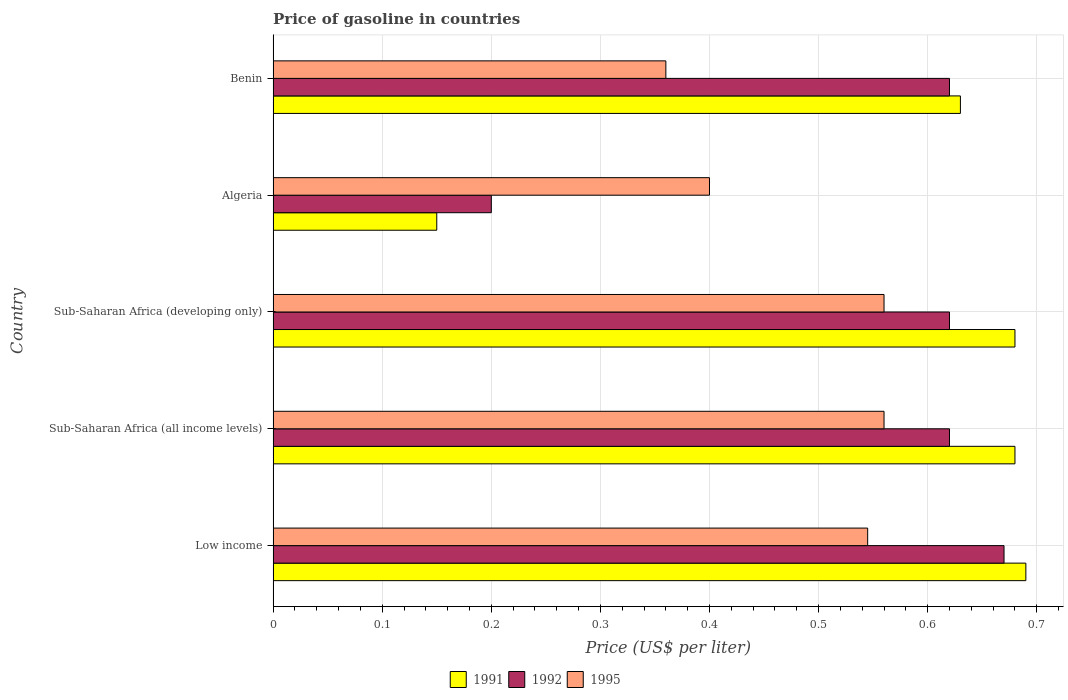How many different coloured bars are there?
Make the answer very short. 3. How many groups of bars are there?
Ensure brevity in your answer.  5. Are the number of bars per tick equal to the number of legend labels?
Provide a short and direct response. Yes. Are the number of bars on each tick of the Y-axis equal?
Offer a terse response. Yes. How many bars are there on the 3rd tick from the top?
Ensure brevity in your answer.  3. What is the price of gasoline in 1992 in Low income?
Offer a terse response. 0.67. Across all countries, what is the maximum price of gasoline in 1992?
Offer a very short reply. 0.67. In which country was the price of gasoline in 1992 maximum?
Keep it short and to the point. Low income. In which country was the price of gasoline in 1992 minimum?
Make the answer very short. Algeria. What is the total price of gasoline in 1991 in the graph?
Offer a very short reply. 2.83. What is the difference between the price of gasoline in 1991 in Algeria and that in Sub-Saharan Africa (all income levels)?
Your answer should be very brief. -0.53. What is the difference between the price of gasoline in 1992 in Algeria and the price of gasoline in 1991 in Sub-Saharan Africa (all income levels)?
Your answer should be very brief. -0.48. What is the average price of gasoline in 1991 per country?
Offer a very short reply. 0.57. What is the difference between the price of gasoline in 1995 and price of gasoline in 1992 in Benin?
Your answer should be compact. -0.26. Is the difference between the price of gasoline in 1995 in Low income and Sub-Saharan Africa (all income levels) greater than the difference between the price of gasoline in 1992 in Low income and Sub-Saharan Africa (all income levels)?
Ensure brevity in your answer.  No. What is the difference between the highest and the second highest price of gasoline in 1995?
Your answer should be very brief. 0. What is the difference between the highest and the lowest price of gasoline in 1992?
Keep it short and to the point. 0.47. In how many countries, is the price of gasoline in 1992 greater than the average price of gasoline in 1992 taken over all countries?
Give a very brief answer. 4. What does the 1st bar from the bottom in Sub-Saharan Africa (all income levels) represents?
Your response must be concise. 1991. Is it the case that in every country, the sum of the price of gasoline in 1992 and price of gasoline in 1995 is greater than the price of gasoline in 1991?
Offer a very short reply. Yes. How many bars are there?
Make the answer very short. 15. Are all the bars in the graph horizontal?
Make the answer very short. Yes. What is the difference between two consecutive major ticks on the X-axis?
Offer a terse response. 0.1. Does the graph contain grids?
Your answer should be compact. Yes. What is the title of the graph?
Make the answer very short. Price of gasoline in countries. Does "1980" appear as one of the legend labels in the graph?
Your answer should be very brief. No. What is the label or title of the X-axis?
Provide a succinct answer. Price (US$ per liter). What is the label or title of the Y-axis?
Provide a short and direct response. Country. What is the Price (US$ per liter) in 1991 in Low income?
Your answer should be compact. 0.69. What is the Price (US$ per liter) in 1992 in Low income?
Keep it short and to the point. 0.67. What is the Price (US$ per liter) of 1995 in Low income?
Your answer should be very brief. 0.55. What is the Price (US$ per liter) of 1991 in Sub-Saharan Africa (all income levels)?
Offer a terse response. 0.68. What is the Price (US$ per liter) of 1992 in Sub-Saharan Africa (all income levels)?
Your answer should be compact. 0.62. What is the Price (US$ per liter) in 1995 in Sub-Saharan Africa (all income levels)?
Your answer should be compact. 0.56. What is the Price (US$ per liter) in 1991 in Sub-Saharan Africa (developing only)?
Offer a very short reply. 0.68. What is the Price (US$ per liter) in 1992 in Sub-Saharan Africa (developing only)?
Your response must be concise. 0.62. What is the Price (US$ per liter) in 1995 in Sub-Saharan Africa (developing only)?
Ensure brevity in your answer.  0.56. What is the Price (US$ per liter) in 1995 in Algeria?
Make the answer very short. 0.4. What is the Price (US$ per liter) in 1991 in Benin?
Provide a succinct answer. 0.63. What is the Price (US$ per liter) in 1992 in Benin?
Make the answer very short. 0.62. What is the Price (US$ per liter) of 1995 in Benin?
Provide a short and direct response. 0.36. Across all countries, what is the maximum Price (US$ per liter) in 1991?
Offer a very short reply. 0.69. Across all countries, what is the maximum Price (US$ per liter) of 1992?
Make the answer very short. 0.67. Across all countries, what is the maximum Price (US$ per liter) of 1995?
Ensure brevity in your answer.  0.56. Across all countries, what is the minimum Price (US$ per liter) of 1992?
Give a very brief answer. 0.2. Across all countries, what is the minimum Price (US$ per liter) in 1995?
Offer a very short reply. 0.36. What is the total Price (US$ per liter) in 1991 in the graph?
Your answer should be compact. 2.83. What is the total Price (US$ per liter) in 1992 in the graph?
Your response must be concise. 2.73. What is the total Price (US$ per liter) in 1995 in the graph?
Keep it short and to the point. 2.42. What is the difference between the Price (US$ per liter) in 1995 in Low income and that in Sub-Saharan Africa (all income levels)?
Keep it short and to the point. -0.01. What is the difference between the Price (US$ per liter) of 1992 in Low income and that in Sub-Saharan Africa (developing only)?
Provide a succinct answer. 0.05. What is the difference between the Price (US$ per liter) in 1995 in Low income and that in Sub-Saharan Africa (developing only)?
Your answer should be compact. -0.01. What is the difference between the Price (US$ per liter) of 1991 in Low income and that in Algeria?
Offer a terse response. 0.54. What is the difference between the Price (US$ per liter) in 1992 in Low income and that in Algeria?
Your answer should be very brief. 0.47. What is the difference between the Price (US$ per liter) in 1995 in Low income and that in Algeria?
Offer a terse response. 0.14. What is the difference between the Price (US$ per liter) of 1995 in Low income and that in Benin?
Your response must be concise. 0.18. What is the difference between the Price (US$ per liter) in 1991 in Sub-Saharan Africa (all income levels) and that in Algeria?
Your response must be concise. 0.53. What is the difference between the Price (US$ per liter) in 1992 in Sub-Saharan Africa (all income levels) and that in Algeria?
Your answer should be very brief. 0.42. What is the difference between the Price (US$ per liter) of 1995 in Sub-Saharan Africa (all income levels) and that in Algeria?
Give a very brief answer. 0.16. What is the difference between the Price (US$ per liter) in 1992 in Sub-Saharan Africa (all income levels) and that in Benin?
Provide a succinct answer. 0. What is the difference between the Price (US$ per liter) in 1991 in Sub-Saharan Africa (developing only) and that in Algeria?
Offer a very short reply. 0.53. What is the difference between the Price (US$ per liter) in 1992 in Sub-Saharan Africa (developing only) and that in Algeria?
Ensure brevity in your answer.  0.42. What is the difference between the Price (US$ per liter) of 1995 in Sub-Saharan Africa (developing only) and that in Algeria?
Keep it short and to the point. 0.16. What is the difference between the Price (US$ per liter) of 1995 in Sub-Saharan Africa (developing only) and that in Benin?
Your answer should be compact. 0.2. What is the difference between the Price (US$ per liter) in 1991 in Algeria and that in Benin?
Ensure brevity in your answer.  -0.48. What is the difference between the Price (US$ per liter) of 1992 in Algeria and that in Benin?
Offer a very short reply. -0.42. What is the difference between the Price (US$ per liter) of 1995 in Algeria and that in Benin?
Give a very brief answer. 0.04. What is the difference between the Price (US$ per liter) of 1991 in Low income and the Price (US$ per liter) of 1992 in Sub-Saharan Africa (all income levels)?
Give a very brief answer. 0.07. What is the difference between the Price (US$ per liter) of 1991 in Low income and the Price (US$ per liter) of 1995 in Sub-Saharan Africa (all income levels)?
Give a very brief answer. 0.13. What is the difference between the Price (US$ per liter) of 1992 in Low income and the Price (US$ per liter) of 1995 in Sub-Saharan Africa (all income levels)?
Provide a succinct answer. 0.11. What is the difference between the Price (US$ per liter) in 1991 in Low income and the Price (US$ per liter) in 1992 in Sub-Saharan Africa (developing only)?
Your answer should be compact. 0.07. What is the difference between the Price (US$ per liter) of 1991 in Low income and the Price (US$ per liter) of 1995 in Sub-Saharan Africa (developing only)?
Offer a terse response. 0.13. What is the difference between the Price (US$ per liter) of 1992 in Low income and the Price (US$ per liter) of 1995 in Sub-Saharan Africa (developing only)?
Offer a very short reply. 0.11. What is the difference between the Price (US$ per liter) of 1991 in Low income and the Price (US$ per liter) of 1992 in Algeria?
Make the answer very short. 0.49. What is the difference between the Price (US$ per liter) in 1991 in Low income and the Price (US$ per liter) in 1995 in Algeria?
Offer a terse response. 0.29. What is the difference between the Price (US$ per liter) in 1992 in Low income and the Price (US$ per liter) in 1995 in Algeria?
Offer a terse response. 0.27. What is the difference between the Price (US$ per liter) in 1991 in Low income and the Price (US$ per liter) in 1992 in Benin?
Keep it short and to the point. 0.07. What is the difference between the Price (US$ per liter) of 1991 in Low income and the Price (US$ per liter) of 1995 in Benin?
Offer a terse response. 0.33. What is the difference between the Price (US$ per liter) of 1992 in Low income and the Price (US$ per liter) of 1995 in Benin?
Provide a short and direct response. 0.31. What is the difference between the Price (US$ per liter) in 1991 in Sub-Saharan Africa (all income levels) and the Price (US$ per liter) in 1995 in Sub-Saharan Africa (developing only)?
Your answer should be compact. 0.12. What is the difference between the Price (US$ per liter) in 1991 in Sub-Saharan Africa (all income levels) and the Price (US$ per liter) in 1992 in Algeria?
Your response must be concise. 0.48. What is the difference between the Price (US$ per liter) of 1991 in Sub-Saharan Africa (all income levels) and the Price (US$ per liter) of 1995 in Algeria?
Your answer should be compact. 0.28. What is the difference between the Price (US$ per liter) of 1992 in Sub-Saharan Africa (all income levels) and the Price (US$ per liter) of 1995 in Algeria?
Make the answer very short. 0.22. What is the difference between the Price (US$ per liter) in 1991 in Sub-Saharan Africa (all income levels) and the Price (US$ per liter) in 1992 in Benin?
Offer a very short reply. 0.06. What is the difference between the Price (US$ per liter) in 1991 in Sub-Saharan Africa (all income levels) and the Price (US$ per liter) in 1995 in Benin?
Your answer should be compact. 0.32. What is the difference between the Price (US$ per liter) in 1992 in Sub-Saharan Africa (all income levels) and the Price (US$ per liter) in 1995 in Benin?
Your answer should be very brief. 0.26. What is the difference between the Price (US$ per liter) of 1991 in Sub-Saharan Africa (developing only) and the Price (US$ per liter) of 1992 in Algeria?
Keep it short and to the point. 0.48. What is the difference between the Price (US$ per liter) in 1991 in Sub-Saharan Africa (developing only) and the Price (US$ per liter) in 1995 in Algeria?
Keep it short and to the point. 0.28. What is the difference between the Price (US$ per liter) of 1992 in Sub-Saharan Africa (developing only) and the Price (US$ per liter) of 1995 in Algeria?
Ensure brevity in your answer.  0.22. What is the difference between the Price (US$ per liter) of 1991 in Sub-Saharan Africa (developing only) and the Price (US$ per liter) of 1992 in Benin?
Your answer should be compact. 0.06. What is the difference between the Price (US$ per liter) in 1991 in Sub-Saharan Africa (developing only) and the Price (US$ per liter) in 1995 in Benin?
Keep it short and to the point. 0.32. What is the difference between the Price (US$ per liter) in 1992 in Sub-Saharan Africa (developing only) and the Price (US$ per liter) in 1995 in Benin?
Ensure brevity in your answer.  0.26. What is the difference between the Price (US$ per liter) in 1991 in Algeria and the Price (US$ per liter) in 1992 in Benin?
Your response must be concise. -0.47. What is the difference between the Price (US$ per liter) in 1991 in Algeria and the Price (US$ per liter) in 1995 in Benin?
Your answer should be very brief. -0.21. What is the difference between the Price (US$ per liter) of 1992 in Algeria and the Price (US$ per liter) of 1995 in Benin?
Provide a succinct answer. -0.16. What is the average Price (US$ per liter) of 1991 per country?
Your answer should be compact. 0.57. What is the average Price (US$ per liter) of 1992 per country?
Your answer should be compact. 0.55. What is the average Price (US$ per liter) in 1995 per country?
Your answer should be compact. 0.48. What is the difference between the Price (US$ per liter) of 1991 and Price (US$ per liter) of 1995 in Low income?
Offer a terse response. 0.14. What is the difference between the Price (US$ per liter) of 1992 and Price (US$ per liter) of 1995 in Low income?
Your answer should be compact. 0.12. What is the difference between the Price (US$ per liter) of 1991 and Price (US$ per liter) of 1995 in Sub-Saharan Africa (all income levels)?
Your response must be concise. 0.12. What is the difference between the Price (US$ per liter) of 1992 and Price (US$ per liter) of 1995 in Sub-Saharan Africa (all income levels)?
Keep it short and to the point. 0.06. What is the difference between the Price (US$ per liter) of 1991 and Price (US$ per liter) of 1995 in Sub-Saharan Africa (developing only)?
Offer a terse response. 0.12. What is the difference between the Price (US$ per liter) of 1991 and Price (US$ per liter) of 1992 in Algeria?
Your answer should be compact. -0.05. What is the difference between the Price (US$ per liter) of 1991 and Price (US$ per liter) of 1992 in Benin?
Your answer should be compact. 0.01. What is the difference between the Price (US$ per liter) in 1991 and Price (US$ per liter) in 1995 in Benin?
Your answer should be very brief. 0.27. What is the difference between the Price (US$ per liter) in 1992 and Price (US$ per liter) in 1995 in Benin?
Make the answer very short. 0.26. What is the ratio of the Price (US$ per liter) in 1991 in Low income to that in Sub-Saharan Africa (all income levels)?
Your answer should be very brief. 1.01. What is the ratio of the Price (US$ per liter) in 1992 in Low income to that in Sub-Saharan Africa (all income levels)?
Your answer should be compact. 1.08. What is the ratio of the Price (US$ per liter) in 1995 in Low income to that in Sub-Saharan Africa (all income levels)?
Ensure brevity in your answer.  0.97. What is the ratio of the Price (US$ per liter) of 1991 in Low income to that in Sub-Saharan Africa (developing only)?
Your answer should be very brief. 1.01. What is the ratio of the Price (US$ per liter) in 1992 in Low income to that in Sub-Saharan Africa (developing only)?
Offer a very short reply. 1.08. What is the ratio of the Price (US$ per liter) of 1995 in Low income to that in Sub-Saharan Africa (developing only)?
Your answer should be compact. 0.97. What is the ratio of the Price (US$ per liter) of 1991 in Low income to that in Algeria?
Offer a terse response. 4.6. What is the ratio of the Price (US$ per liter) of 1992 in Low income to that in Algeria?
Ensure brevity in your answer.  3.35. What is the ratio of the Price (US$ per liter) of 1995 in Low income to that in Algeria?
Offer a very short reply. 1.36. What is the ratio of the Price (US$ per liter) of 1991 in Low income to that in Benin?
Offer a very short reply. 1.1. What is the ratio of the Price (US$ per liter) of 1992 in Low income to that in Benin?
Keep it short and to the point. 1.08. What is the ratio of the Price (US$ per liter) in 1995 in Low income to that in Benin?
Your answer should be compact. 1.51. What is the ratio of the Price (US$ per liter) in 1992 in Sub-Saharan Africa (all income levels) to that in Sub-Saharan Africa (developing only)?
Offer a terse response. 1. What is the ratio of the Price (US$ per liter) of 1995 in Sub-Saharan Africa (all income levels) to that in Sub-Saharan Africa (developing only)?
Offer a terse response. 1. What is the ratio of the Price (US$ per liter) in 1991 in Sub-Saharan Africa (all income levels) to that in Algeria?
Make the answer very short. 4.53. What is the ratio of the Price (US$ per liter) of 1991 in Sub-Saharan Africa (all income levels) to that in Benin?
Provide a short and direct response. 1.08. What is the ratio of the Price (US$ per liter) in 1995 in Sub-Saharan Africa (all income levels) to that in Benin?
Ensure brevity in your answer.  1.56. What is the ratio of the Price (US$ per liter) in 1991 in Sub-Saharan Africa (developing only) to that in Algeria?
Give a very brief answer. 4.53. What is the ratio of the Price (US$ per liter) of 1991 in Sub-Saharan Africa (developing only) to that in Benin?
Provide a succinct answer. 1.08. What is the ratio of the Price (US$ per liter) in 1992 in Sub-Saharan Africa (developing only) to that in Benin?
Make the answer very short. 1. What is the ratio of the Price (US$ per liter) of 1995 in Sub-Saharan Africa (developing only) to that in Benin?
Your response must be concise. 1.56. What is the ratio of the Price (US$ per liter) in 1991 in Algeria to that in Benin?
Your response must be concise. 0.24. What is the ratio of the Price (US$ per liter) of 1992 in Algeria to that in Benin?
Make the answer very short. 0.32. What is the difference between the highest and the second highest Price (US$ per liter) in 1991?
Your answer should be compact. 0.01. What is the difference between the highest and the second highest Price (US$ per liter) of 1992?
Ensure brevity in your answer.  0.05. What is the difference between the highest and the lowest Price (US$ per liter) in 1991?
Ensure brevity in your answer.  0.54. What is the difference between the highest and the lowest Price (US$ per liter) of 1992?
Offer a very short reply. 0.47. What is the difference between the highest and the lowest Price (US$ per liter) of 1995?
Make the answer very short. 0.2. 